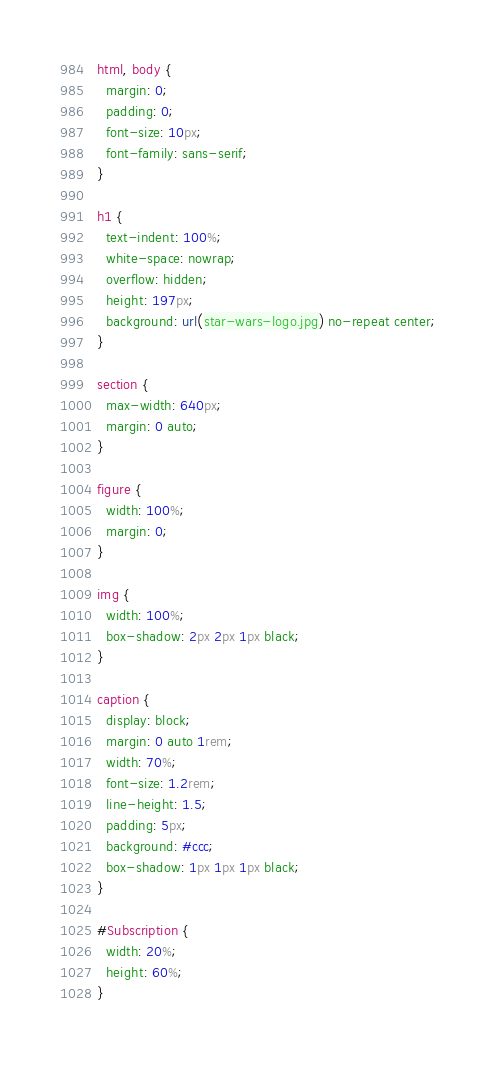Convert code to text. <code><loc_0><loc_0><loc_500><loc_500><_CSS_>html, body {
  margin: 0;
  padding: 0;
  font-size: 10px;
  font-family: sans-serif;
}

h1 {
  text-indent: 100%;
  white-space: nowrap;
  overflow: hidden;
  height: 197px;
  background: url(star-wars-logo.jpg) no-repeat center;
}

section {
  max-width: 640px;
  margin: 0 auto;
}

figure {
  width: 100%;
  margin: 0;
}

img {
  width: 100%;	
  box-shadow: 2px 2px 1px black;
}

caption {
  display: block;
  margin: 0 auto 1rem;
  width: 70%;
  font-size: 1.2rem;
  line-height: 1.5;
  padding: 5px;
  background: #ccc;
  box-shadow: 1px 1px 1px black;
}

#Subscription {
  width: 20%;
  height: 60%;
}
</code> 